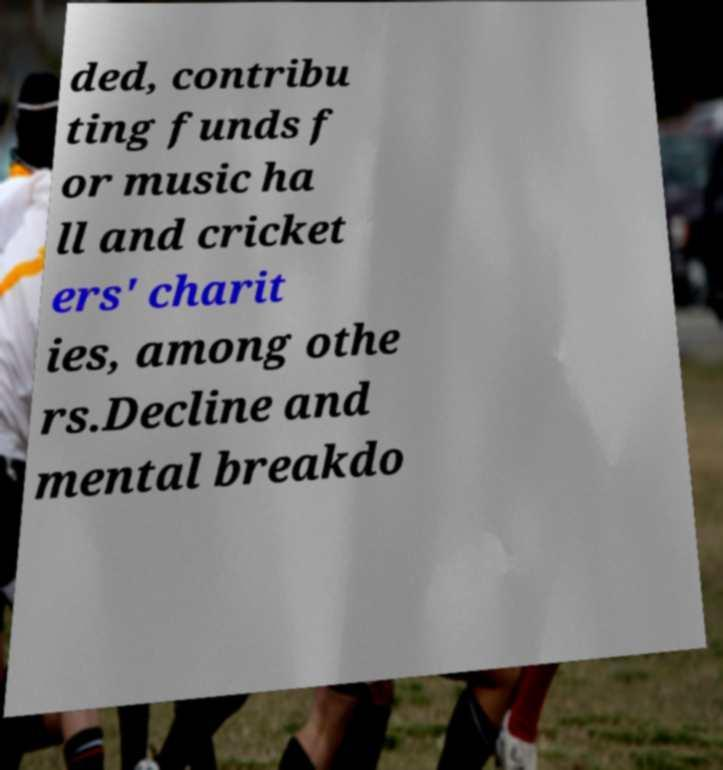There's text embedded in this image that I need extracted. Can you transcribe it verbatim? ded, contribu ting funds f or music ha ll and cricket ers' charit ies, among othe rs.Decline and mental breakdo 